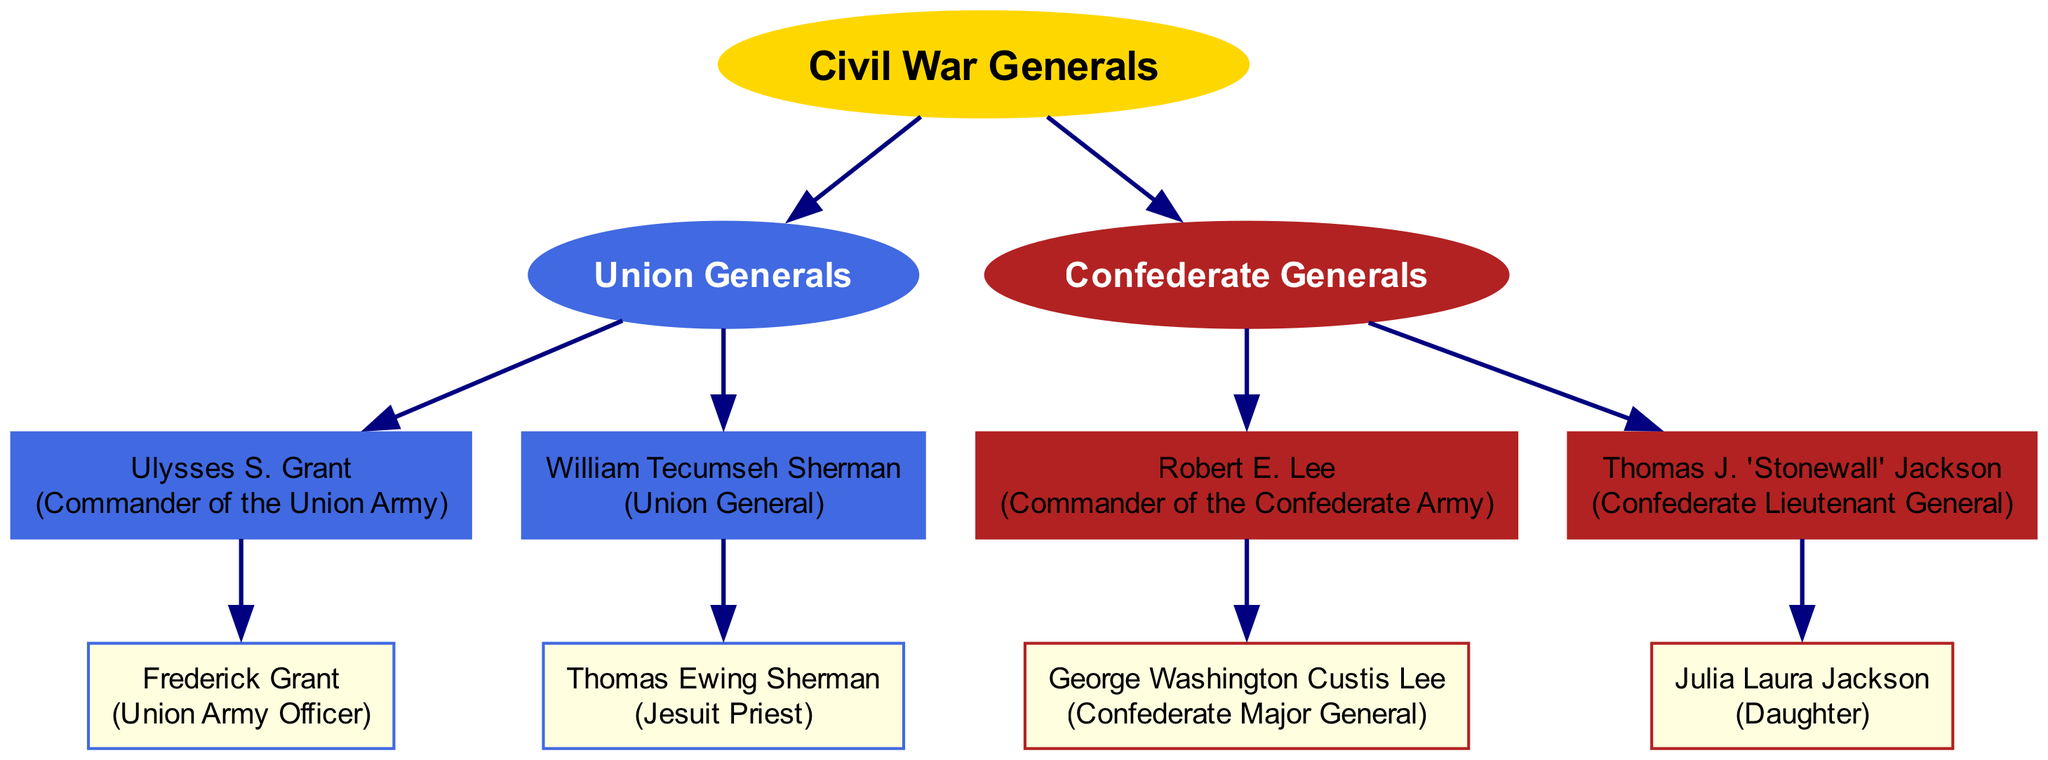What is the role of Ulysses S. Grant? Ulysses S. Grant is specifically labeled as the "Commander of the Union Army" in the diagram and is directly connected to the Union Generals branch.
Answer: Commander of the Union Army How many children does Robert E. Lee have? In the diagram, when examining the node for Robert E. Lee, it shows he has one child, George Washington Custis Lee, directly connected below him.
Answer: 1 Which general's child is a Jesuit Priest? The diagram identifies Thomas Ewing Sherman, connected to William Tecumseh Sherman, as the "Jesuit Priest", indicating that he is the child of that general.
Answer: William Tecumseh Sherman What color represents the Union Generals branch? Looking at the branch labeled "Union Generals", it is highlighted in royal blue, which can be observed from the diagram’s color scheme for this branch.
Answer: royal blue Who is the daughter of Thomas J. 'Stonewall' Jackson? The diagram points out that Julia Laura Jackson is directly connected under the node for Thomas J. 'Stonewall' Jackson, indicating their familial relationship.
Answer: Julia Laura Jackson Which general from the Union has only one child? Upon reviewing the Union Generals, Ulysses S. Grant has a single child, Frederick Grant, making him the general that fits this criteria.
Answer: Ulysses S. Grant Who commands the Confederate Army? The diagram specifies that Robert E. Lee is noted as the "Commander of the Confederate Army", making him the individual who holds this title.
Answer: Robert E. Lee What is the relationship between Frederick Grant and Ulysses S. Grant? The diagram illustrates that Frederick Grant is a direct descendant of Ulysses S. Grant, as he is shown as his child connected beneath him.
Answer: Child Which Confederate general is associated with the title "Lieutenant General"? The diagram indicates that Thomas J. 'Stonewall' Jackson holds the title of "Confederate Lieutenant General", which is detailed within his node.
Answer: Thomas J. 'Stonewall' Jackson 